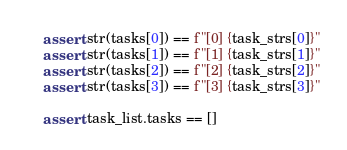Convert code to text. <code><loc_0><loc_0><loc_500><loc_500><_Python_>
    assert str(tasks[0]) == f"[0] {task_strs[0]}"
    assert str(tasks[1]) == f"[1] {task_strs[1]}"
    assert str(tasks[2]) == f"[2] {task_strs[2]}"
    assert str(tasks[3]) == f"[3] {task_strs[3]}"

    assert task_list.tasks == []
</code> 